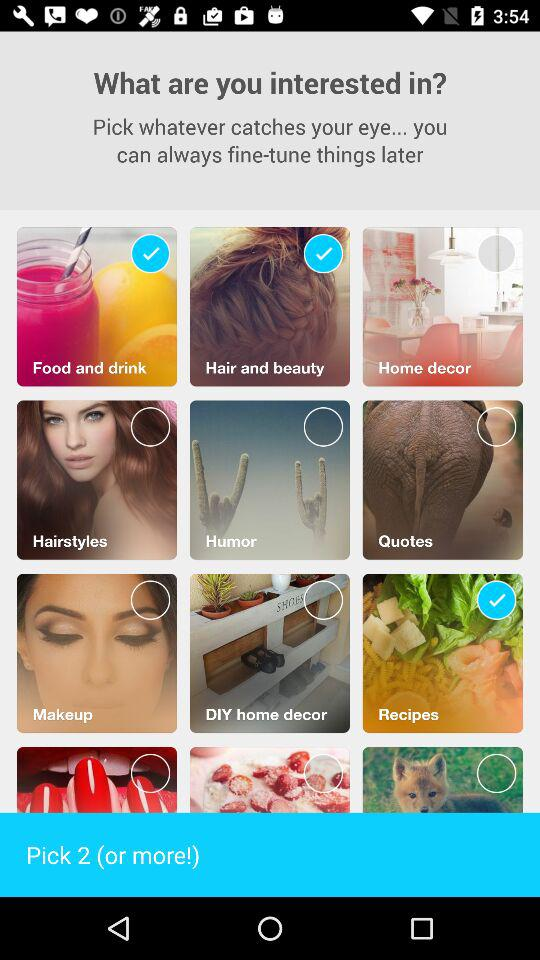How many options are required to be picked? The required options to be picked are 2 or more. 